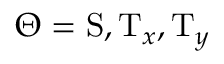Convert formula to latex. <formula><loc_0><loc_0><loc_500><loc_500>\Theta = { S } , { T } _ { x } , { T } _ { y }</formula> 